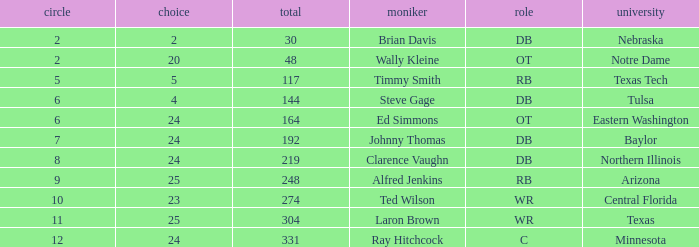What are the total rounds for the texas college and has a pick smaller than 25? 0.0. Can you parse all the data within this table? {'header': ['circle', 'choice', 'total', 'moniker', 'role', 'university'], 'rows': [['2', '2', '30', 'Brian Davis', 'DB', 'Nebraska'], ['2', '20', '48', 'Wally Kleine', 'OT', 'Notre Dame'], ['5', '5', '117', 'Timmy Smith', 'RB', 'Texas Tech'], ['6', '4', '144', 'Steve Gage', 'DB', 'Tulsa'], ['6', '24', '164', 'Ed Simmons', 'OT', 'Eastern Washington'], ['7', '24', '192', 'Johnny Thomas', 'DB', 'Baylor'], ['8', '24', '219', 'Clarence Vaughn', 'DB', 'Northern Illinois'], ['9', '25', '248', 'Alfred Jenkins', 'RB', 'Arizona'], ['10', '23', '274', 'Ted Wilson', 'WR', 'Central Florida'], ['11', '25', '304', 'Laron Brown', 'WR', 'Texas'], ['12', '24', '331', 'Ray Hitchcock', 'C', 'Minnesota']]} 